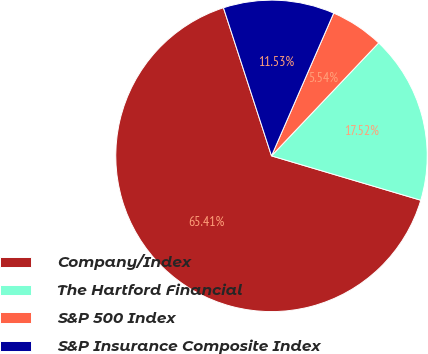Convert chart to OTSL. <chart><loc_0><loc_0><loc_500><loc_500><pie_chart><fcel>Company/Index<fcel>The Hartford Financial<fcel>S&P 500 Index<fcel>S&P Insurance Composite Index<nl><fcel>65.41%<fcel>17.52%<fcel>5.54%<fcel>11.53%<nl></chart> 